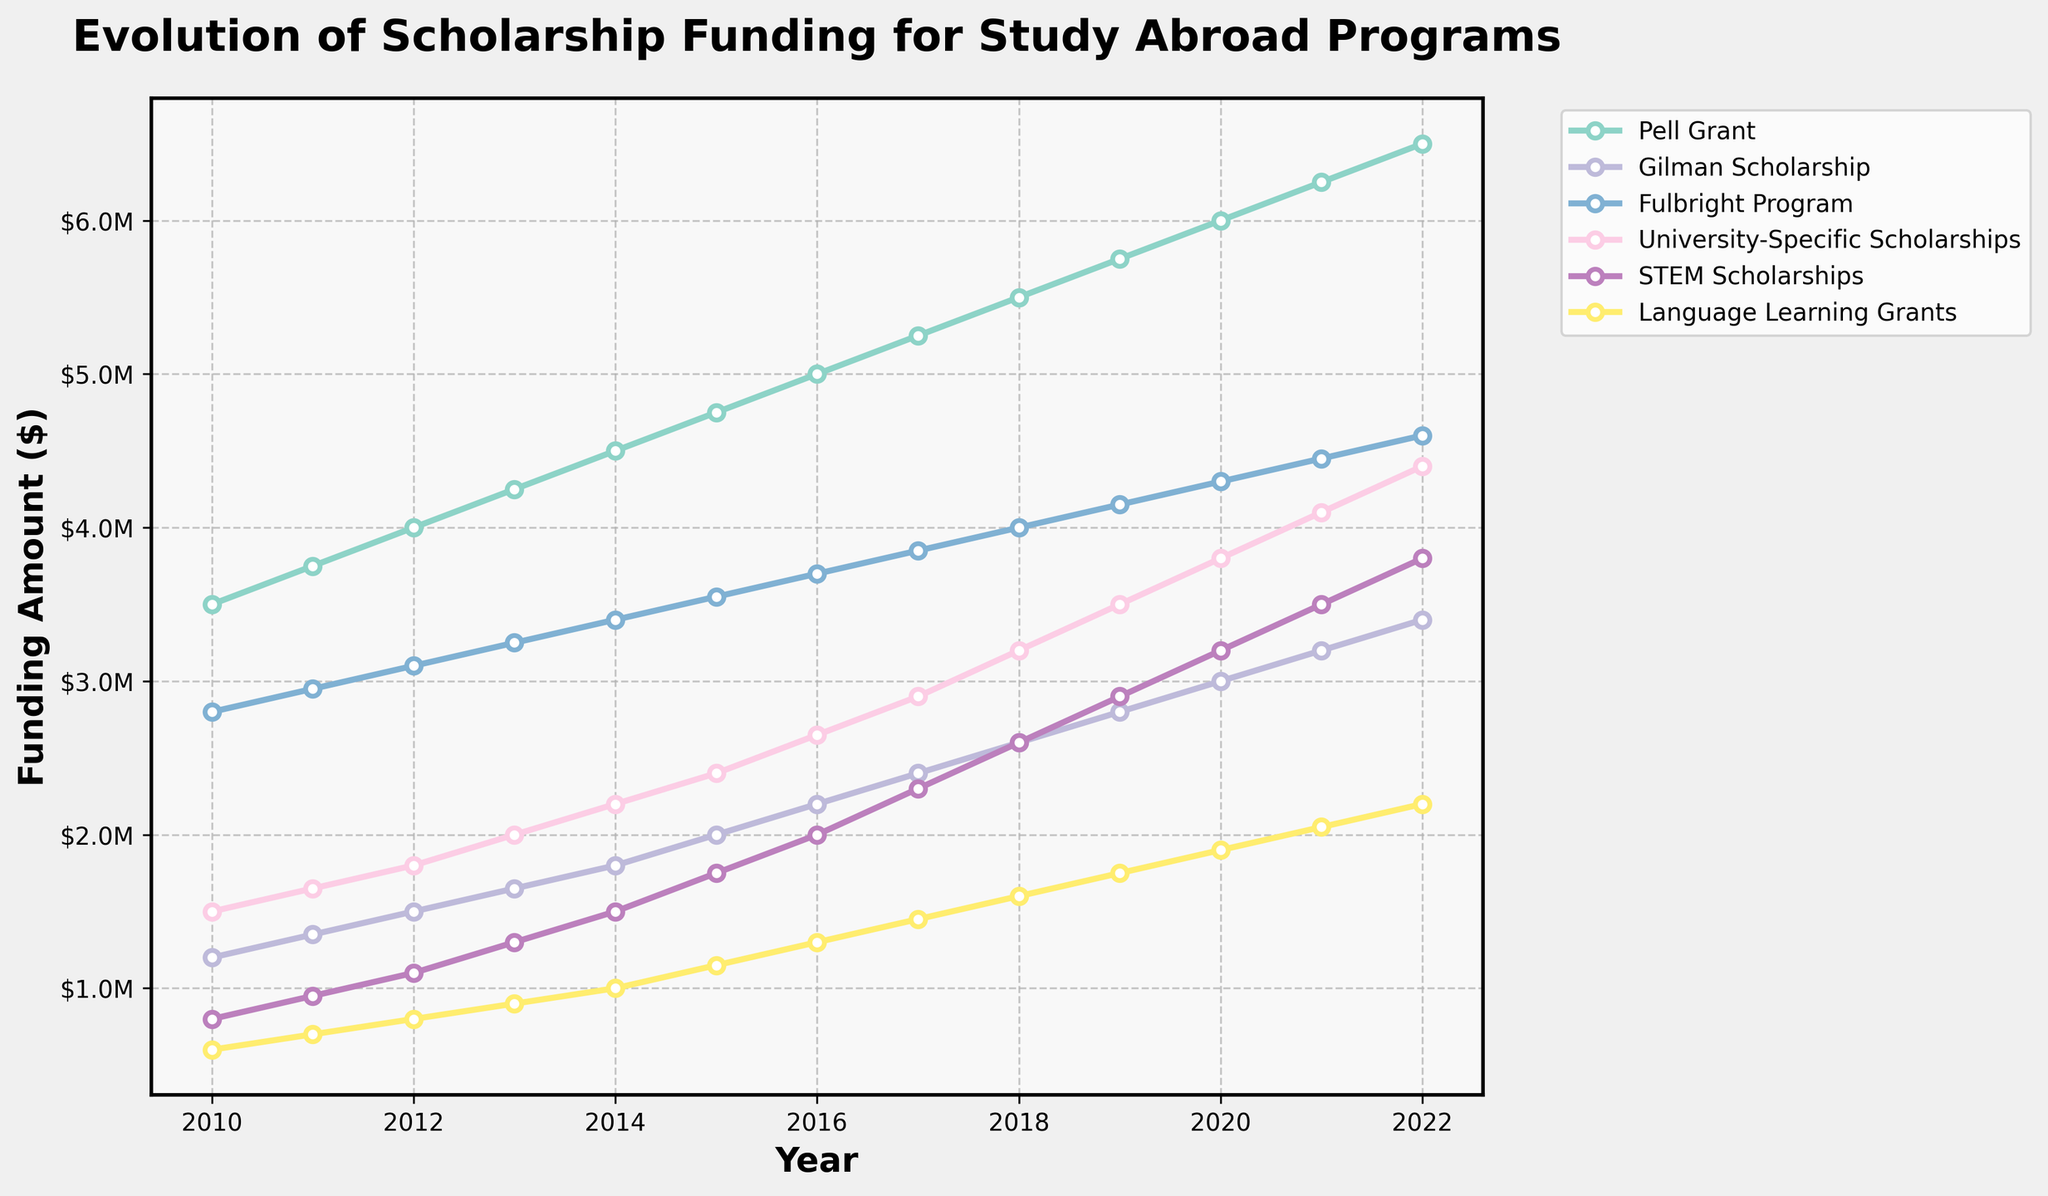Which scholarship had the highest funding in 2022? Look at the end of the plot that represents 2022. Identify the highest line, which corresponds to the Pell Grant.
Answer: Pell Grant How much did the funding for the Gilman Scholarship increase from 2010 to 2022? Locate the starting point of the Gilman Scholarship in 2010 ($1,200,000) and the endpoint in 2022 ($3,400,000). Subtract the 2010 value from the 2022 value: $3,400,000 - $1,200,000.
Answer: $2,200,000 Which year showed the largest increase in funding for STEM Scholarships compared to the previous year? Track the line representing STEM Scholarships and identify the year with the steepest rise. The biggest jump is from 2015 to 2016, where the funding jumped from $1,750,000 to $2,000,000.
Answer: 2016 In which year did University-Specific Scholarships and Fulbright Program funding first exceed $4,000,000? Follow the lines representing University-Specific Scholarships and the Fulbright Program. The year where both lines first cross the $4,000,000 mark is 2022.
Answer: 2022 Which funding type consistently increased every year without any decreases? Follow the lines of each funding type. The Pell Grant shows a consistent increase every year.
Answer: Pell Grant What is the difference between the funding for Language Learning Grants and University-Specific Scholarships in 2020? Check the 2020 funding for both: Language Learning Grants ($1,900,000) and University-Specific Scholarships ($3,800,000). Subtract the former from the latter: $3,800,000 - $1,900,000.
Answer: $1,900,000 In 2018, was the funding for STEM Scholarships higher or lower than the funding for the Gilman Scholarship? Compare the 2018 values: STEM Scholarships ($2,600,000) and Gilman Scholarship ($2,600,000). Both are equal.
Answer: Equal What is the average annual increase in funding for the Fulbright Program from 2010 to 2022? First, find the total increase from 2010 ($2,800,000) to 2022 ($4,600,000): $4,600,000 - $2,800,000 = $1,800,000. Then divide by the number of years (2022 - 2010 = 12): $1,800,000 / 12.
Answer: $150,000 Which scholarships had funding that reached $3,000,000 by 2018? Look at the end of the plot representing 2018. Identify the lines that reached at least $3,000,000 in 2018. These are Pell Grant and Fulbright Program.
Answer: Pell Grant, Fulbright Program 